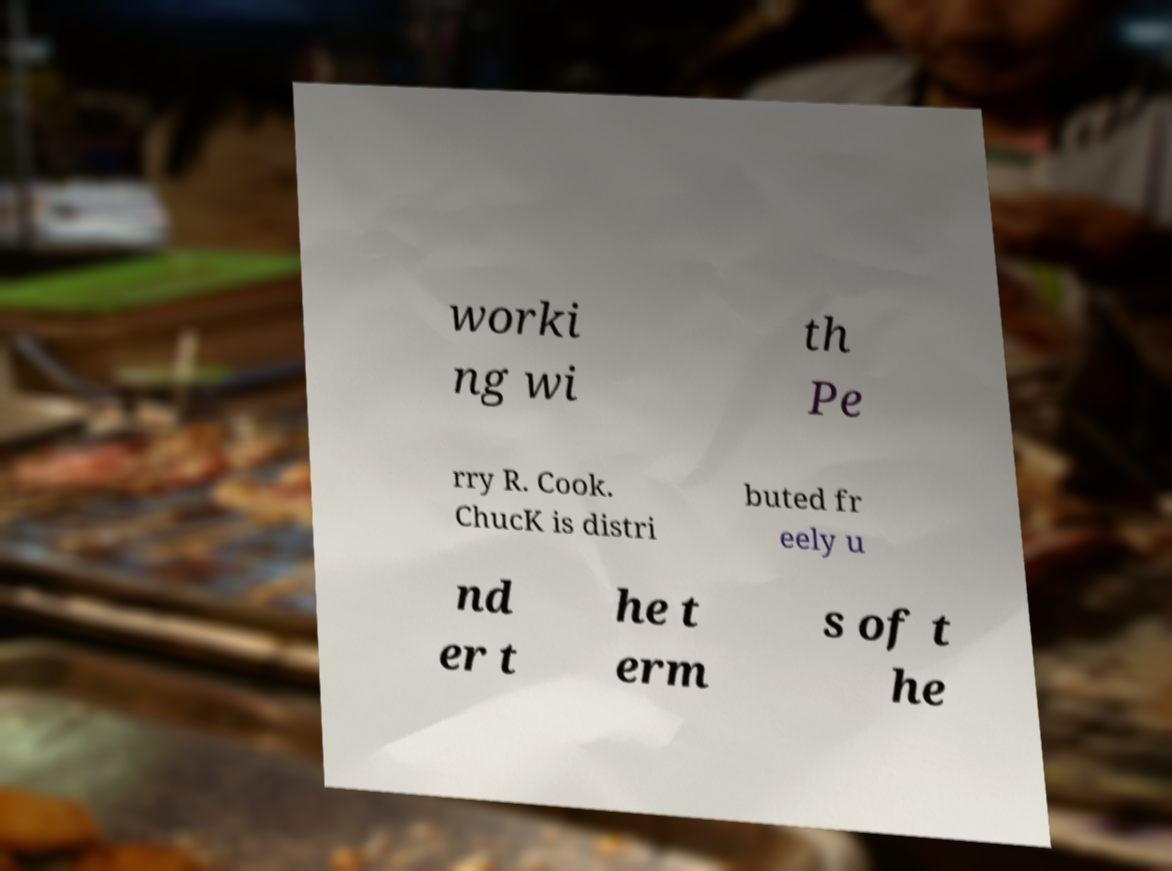Please read and relay the text visible in this image. What does it say? worki ng wi th Pe rry R. Cook. ChucK is distri buted fr eely u nd er t he t erm s of t he 